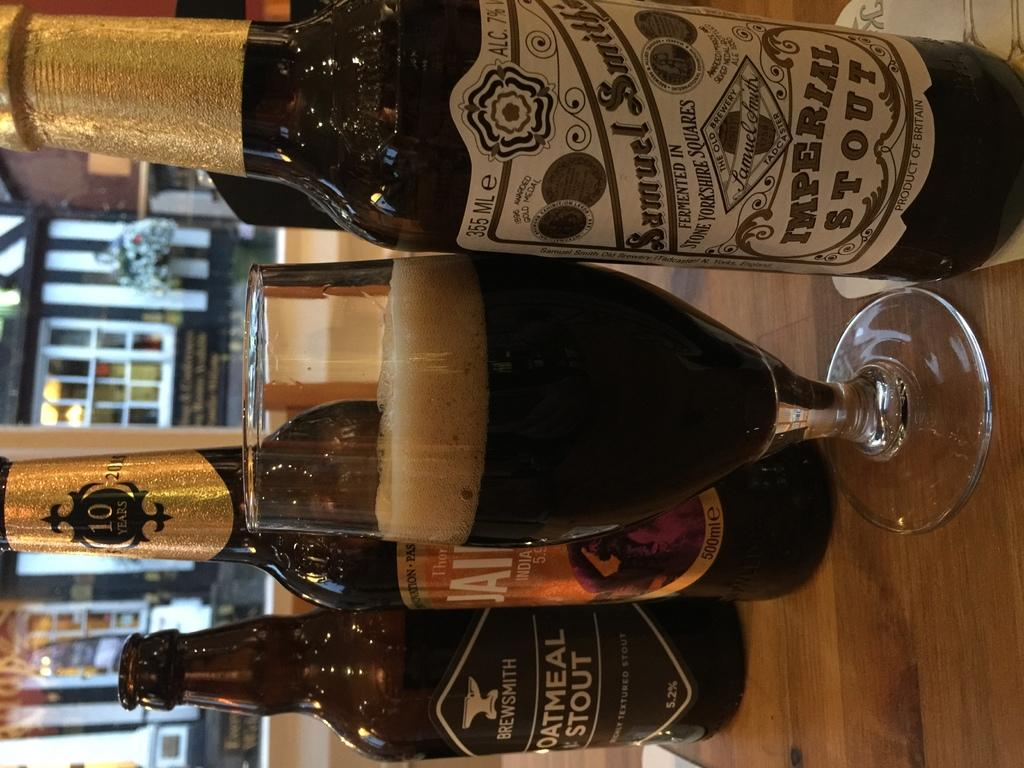What type of containers are visible in the image? There are bottles in the image. What other type of container is present in the image? There is a glass in the image. Where are the bottles and glass located? The bottles and glass are on a surface. What can be seen in the background of the image? There is a building with glass doors in the background of the image. How many boys are eating pie in the image? There are no boys or pie present in the image. 